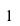Convert formula to latex. <formula><loc_0><loc_0><loc_500><loc_500>1</formula> 